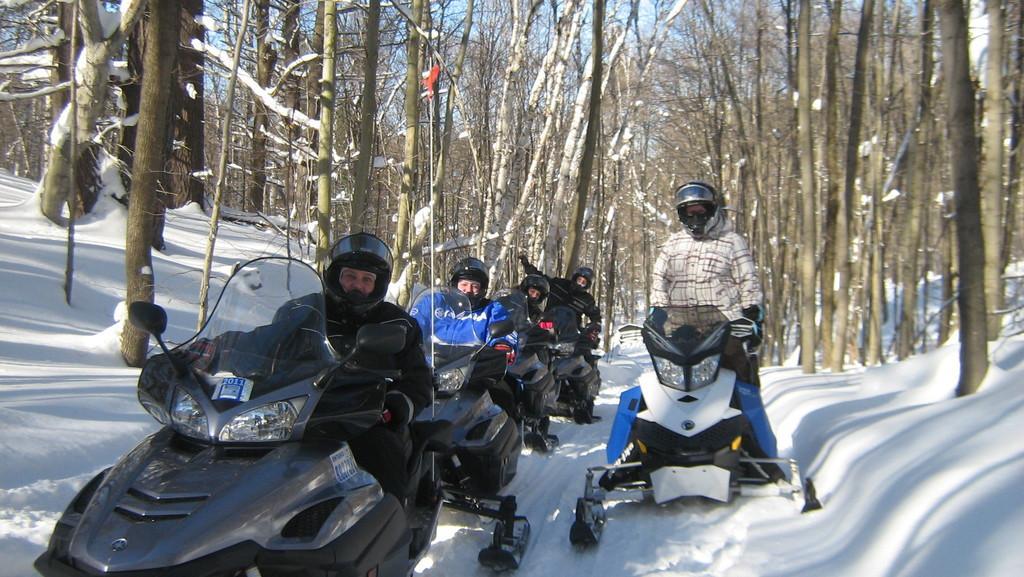Could you give a brief overview of what you see in this image? There are people present on the motorbikes as we can see at the bottom of this image. There are trees in the background and the sky is at the top of this image. 